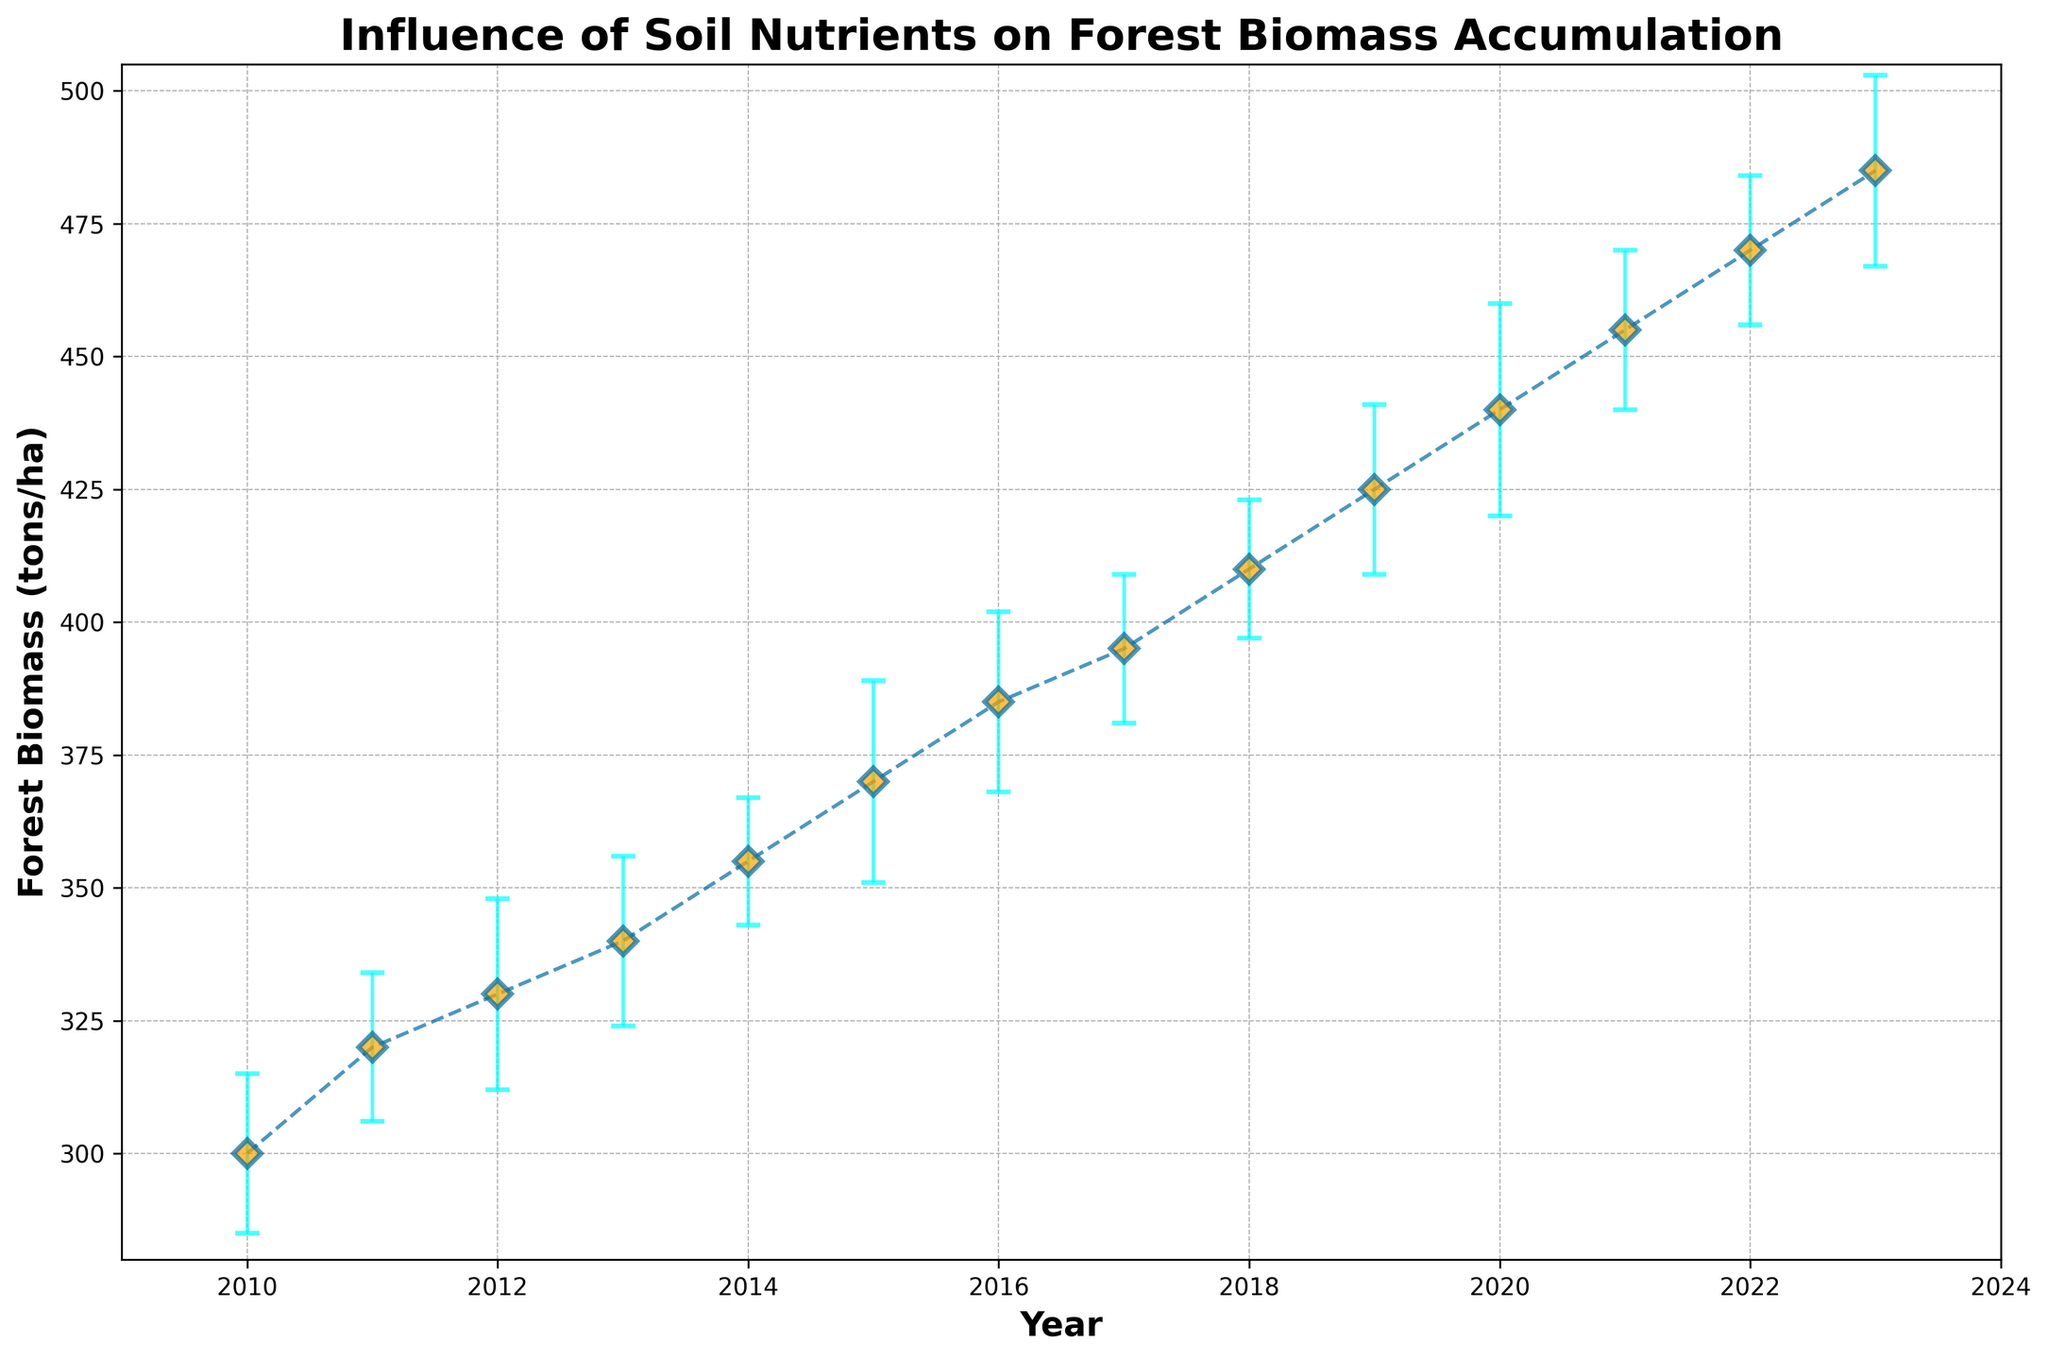What is the general trend of forest biomass accumulation from 2010 to 2023? The general trend shows a steady increase in forest biomass accumulation over the years from 300 tons/ha in 2010 to 485 tons/ha in 2023, as depicted by the upward-moving line with each data point.
Answer: Steady increase What is the average forest biomass accumulation for the years 2015, 2017, and 2019? The forest biomass values for 2015, 2017, and 2019 are 370, 395, and 425 tons/ha, respectively. Summing these values gives 370 + 395 + 425 = 1190. Dividing by 3 provides the average: 1190 / 3 = 397.
Answer: 397 tons/ha In which year did the forest biomass have the highest accumulation? The highest data point on the graph marked with an orange diamond and a value of 485 tons/ha occurs in 2023.
Answer: 2023 How does the forest biomass in 2020 compare to that in 2018? In 2020, the forest biomass is 440 tons/ha, while in 2018, it is 410 tons/ha. Therefore, 2020 has a higher forest biomass accumulation than 2018.
Answer: Higher in 2020 What is the range of error margins observed in forest biomass accumulation over the years? The error margins range from the lowest value of 12 tons/ha in 2014 to the highest value of 20 tons/ha in 2020.
Answer: 12 to 20 tons/ha What is the difference in forest biomass accumulation between 2012 and 2015? In 2012, the forest biomass accumulation is 330 tons/ha, and in 2015, it is 370 tons/ha. The difference is 370 - 330 = 40 tons/ha.
Answer: 40 tons/ha Which year shows the smallest error margin, and what does that indicate visually? The smallest error margin is 12 tons/ha, observed in 2014, indicating less uncertainty or variability in the forest biomass measurement for that year, represented by the shorter error bar.
Answer: 2014 What is the compounded increase in forest biomass from 2010 to 2023? The compounded increase is the final biomass minus the initial biomass: 485 tons/ha in 2023 minus 300 tons/ha in 2010, which equates to 485 - 300 = 185 tons/ha.
Answer: 185 tons/ha 